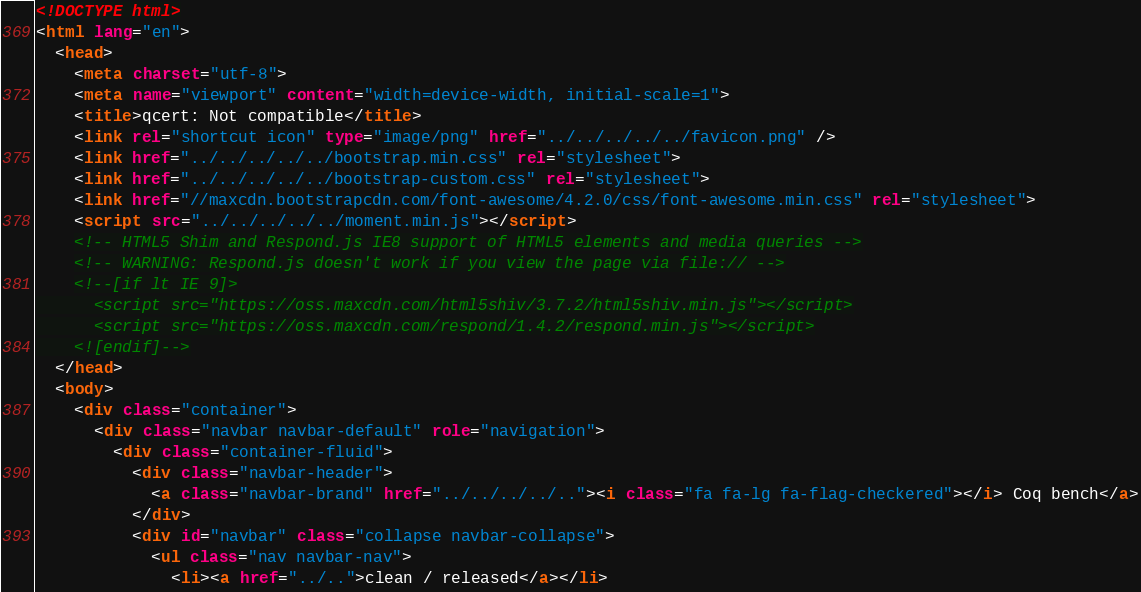Convert code to text. <code><loc_0><loc_0><loc_500><loc_500><_HTML_><!DOCTYPE html>
<html lang="en">
  <head>
    <meta charset="utf-8">
    <meta name="viewport" content="width=device-width, initial-scale=1">
    <title>qcert: Not compatible</title>
    <link rel="shortcut icon" type="image/png" href="../../../../../favicon.png" />
    <link href="../../../../../bootstrap.min.css" rel="stylesheet">
    <link href="../../../../../bootstrap-custom.css" rel="stylesheet">
    <link href="//maxcdn.bootstrapcdn.com/font-awesome/4.2.0/css/font-awesome.min.css" rel="stylesheet">
    <script src="../../../../../moment.min.js"></script>
    <!-- HTML5 Shim and Respond.js IE8 support of HTML5 elements and media queries -->
    <!-- WARNING: Respond.js doesn't work if you view the page via file:// -->
    <!--[if lt IE 9]>
      <script src="https://oss.maxcdn.com/html5shiv/3.7.2/html5shiv.min.js"></script>
      <script src="https://oss.maxcdn.com/respond/1.4.2/respond.min.js"></script>
    <![endif]-->
  </head>
  <body>
    <div class="container">
      <div class="navbar navbar-default" role="navigation">
        <div class="container-fluid">
          <div class="navbar-header">
            <a class="navbar-brand" href="../../../../.."><i class="fa fa-lg fa-flag-checkered"></i> Coq bench</a>
          </div>
          <div id="navbar" class="collapse navbar-collapse">
            <ul class="nav navbar-nav">
              <li><a href="../..">clean / released</a></li></code> 